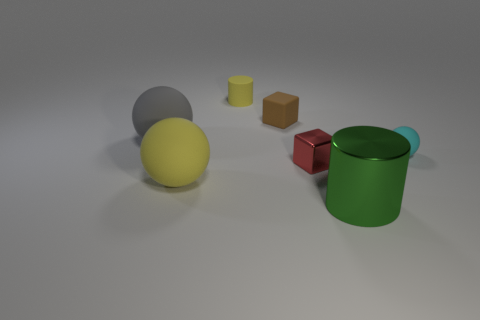Subtract 1 blocks. How many blocks are left? 1 Add 2 big yellow spheres. How many objects exist? 9 Subtract all small rubber balls. How many balls are left? 2 Add 4 tiny red metal cubes. How many tiny red metal cubes are left? 5 Add 7 large red matte things. How many large red matte things exist? 7 Subtract all cyan spheres. How many spheres are left? 2 Subtract 0 gray blocks. How many objects are left? 7 Subtract all balls. How many objects are left? 4 Subtract all yellow cylinders. Subtract all purple blocks. How many cylinders are left? 1 Subtract all purple spheres. How many yellow cylinders are left? 1 